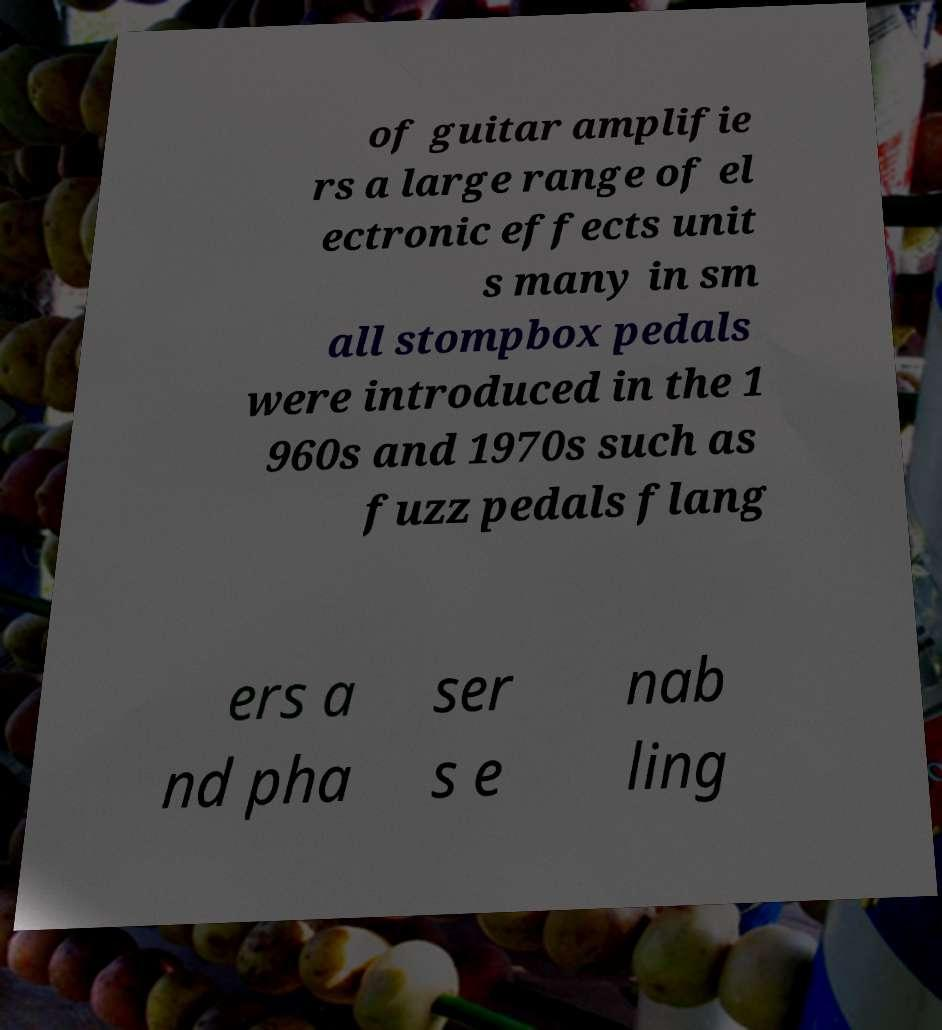Please identify and transcribe the text found in this image. of guitar amplifie rs a large range of el ectronic effects unit s many in sm all stompbox pedals were introduced in the 1 960s and 1970s such as fuzz pedals flang ers a nd pha ser s e nab ling 